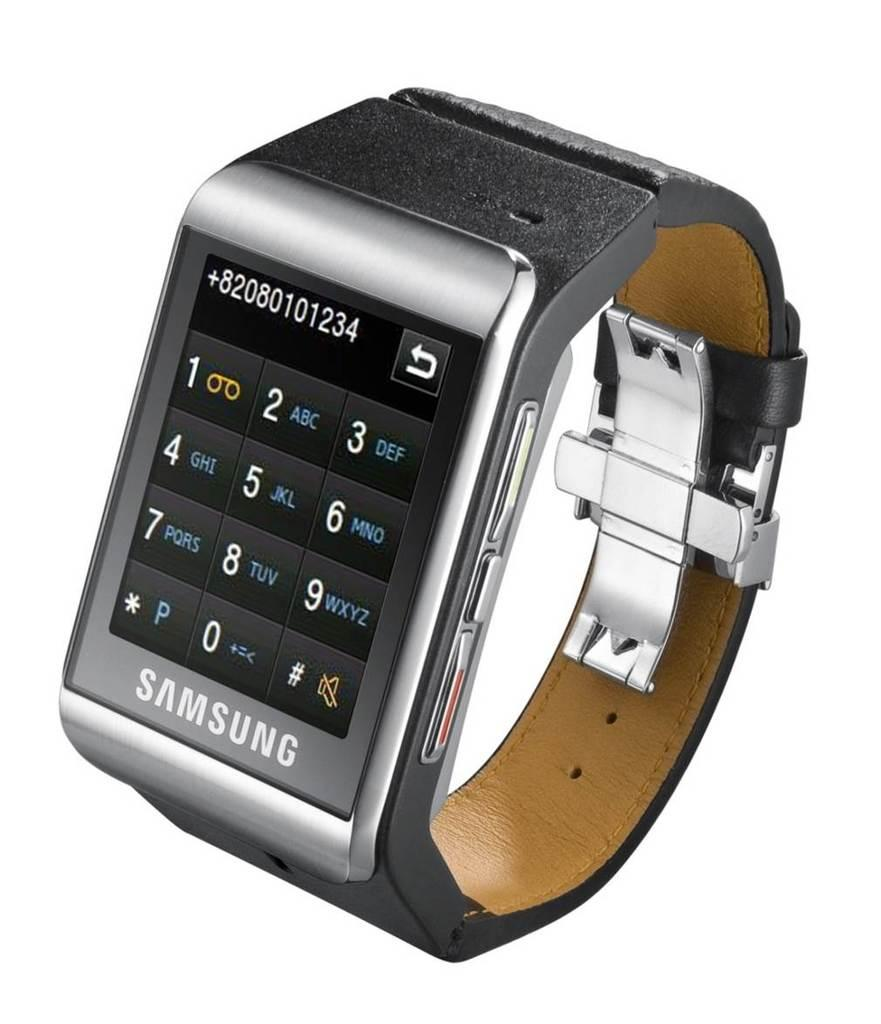Provide a one-sentence caption for the provided image. A Samsung watch is dialing a phone number. 